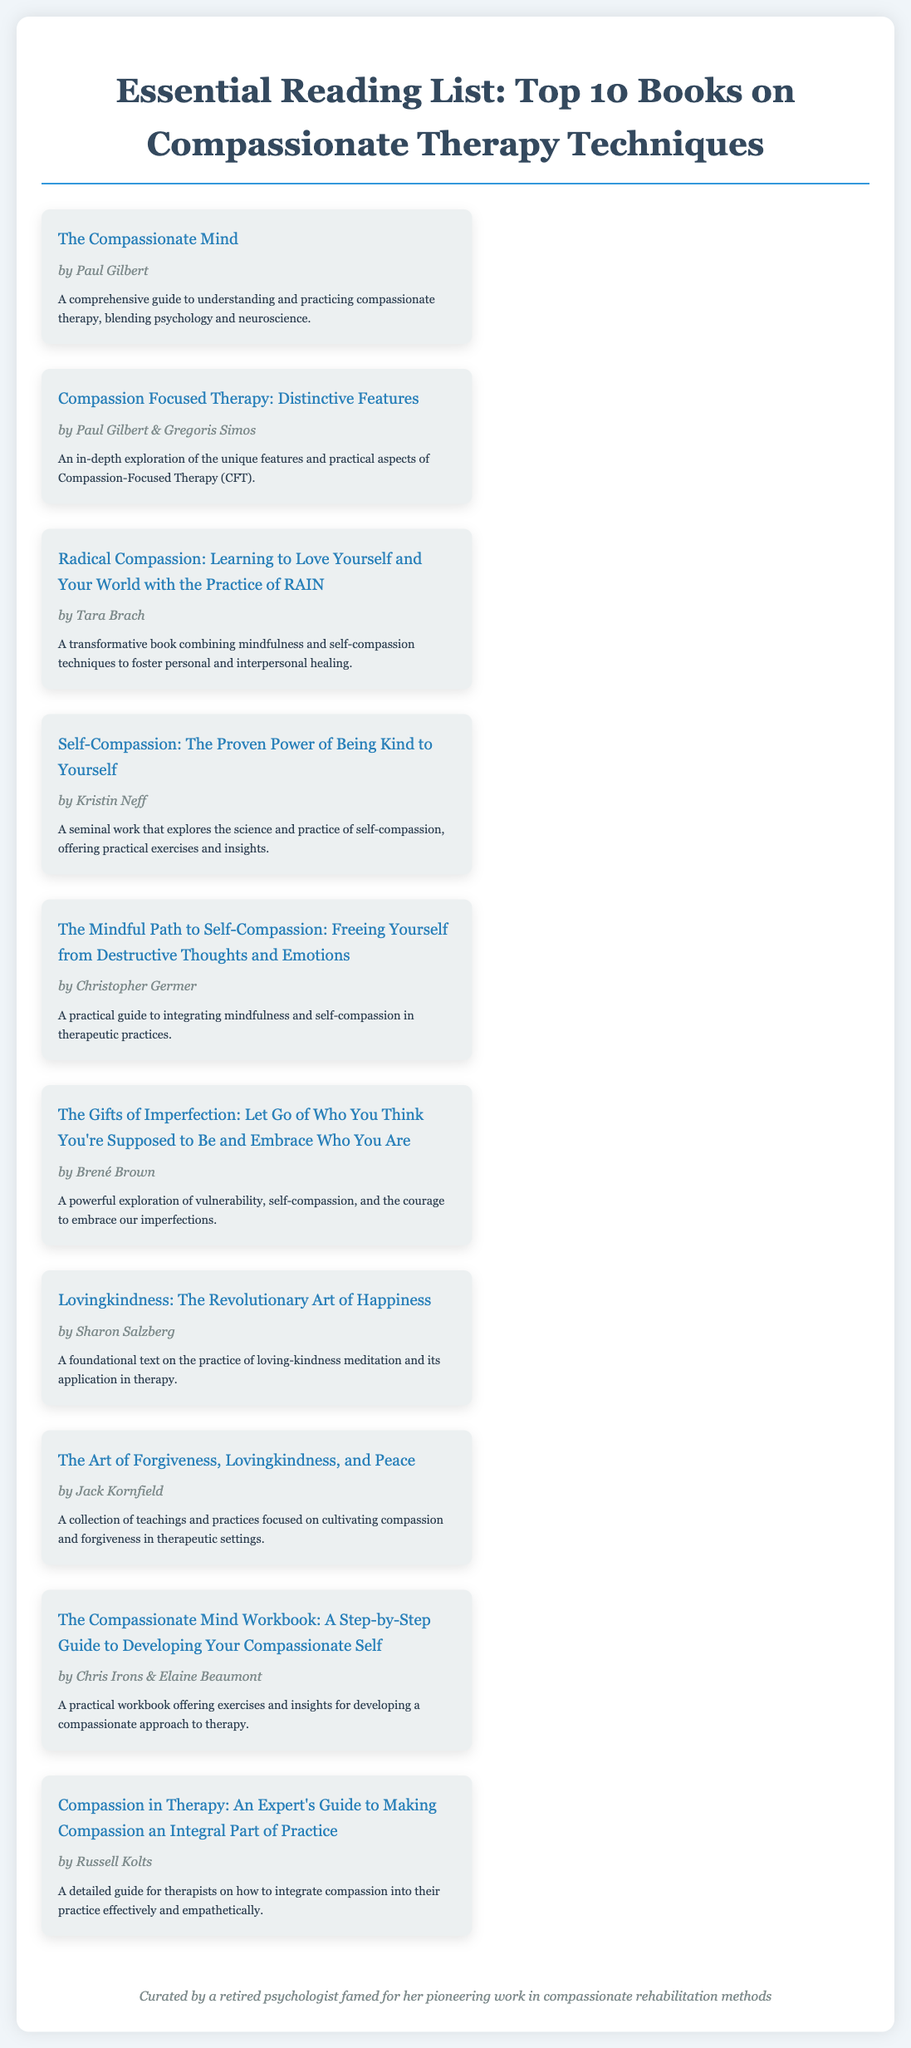What is the title of the first book? The title refers to the first listed book in the infographic.
Answer: The Compassionate Mind Who is the author of "Radical Compassion"? This question asks for the author's name of a specific book.
Answer: Tara Brach How many authors contributed to "Compassion Focused Therapy: Distinctive Features"? This refers to how many individuals are credited as authors of the book.
Answer: Two Which book discusses self-compassion practices? This question seeks a title related to self-compassion from the document.
Answer: Self-Compassion: The Proven Power of Being Kind to Yourself What is the primary focus of "The Gifts of Imperfection"? This asks for a main theme of a specific book listed in the document.
Answer: Vulnerability and self-compassion Which book emphasizes loving-kindness meditation? This question looks for the title that centers on a specific meditation practice.
Answer: Lovingkindness: The Revolutionary Art of Happiness How many books are listed in total? This seeks a count of how many books appear in the infographic.
Answer: Ten Who authored "The Art of Forgiveness, Lovingkindness, and Peace"? This question asks for the author's name for a specific book in the list.
Answer: Jack Kornfield What is the central theme of "Compassion in Therapy"? This asks for the focus or theme of a designated book.
Answer: Integrating compassion into therapy 